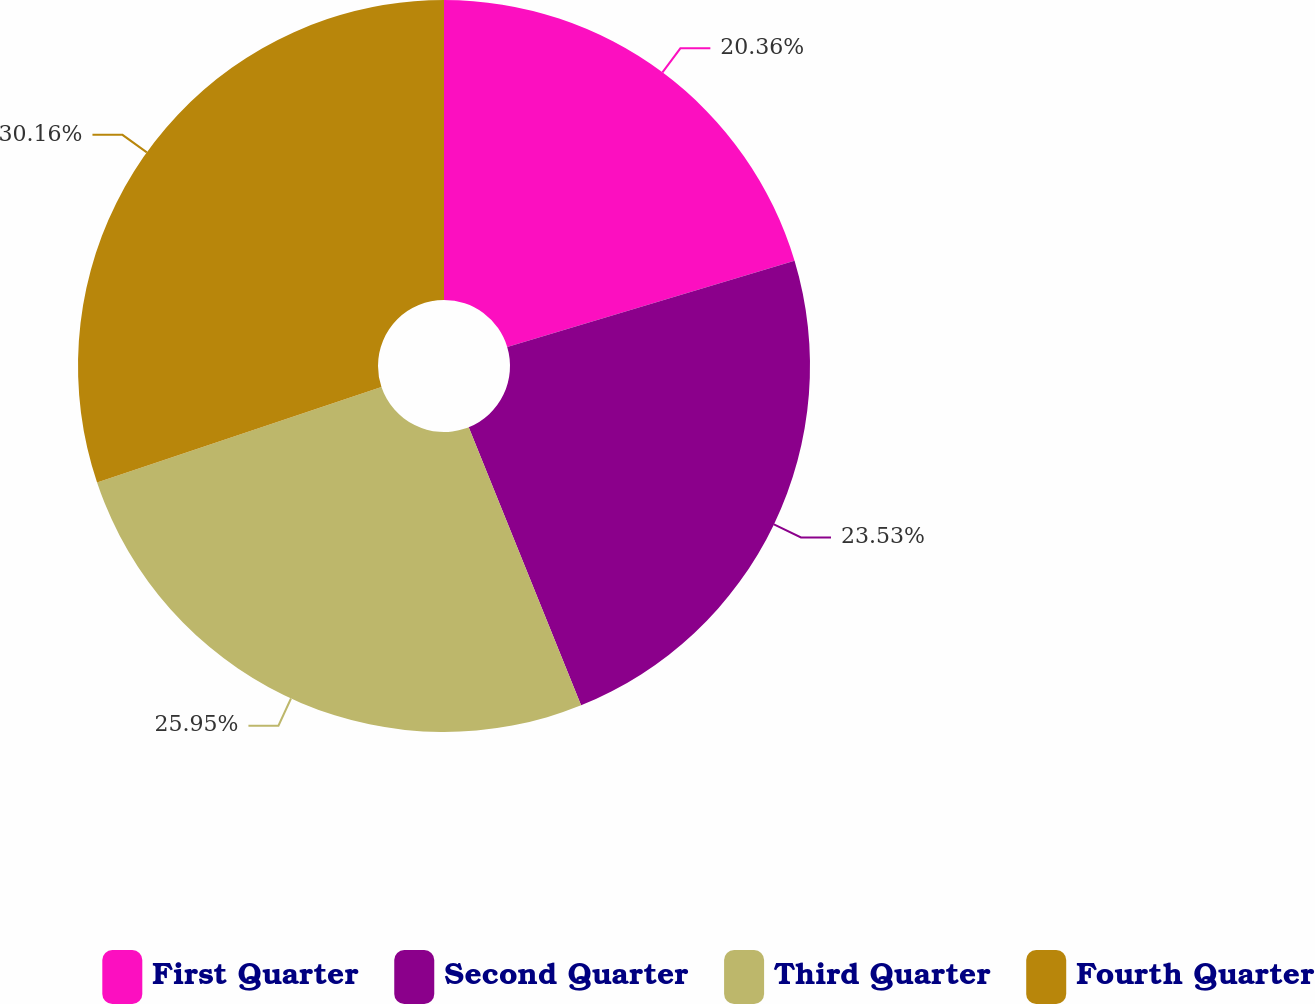Convert chart to OTSL. <chart><loc_0><loc_0><loc_500><loc_500><pie_chart><fcel>First Quarter<fcel>Second Quarter<fcel>Third Quarter<fcel>Fourth Quarter<nl><fcel>20.36%<fcel>23.53%<fcel>25.95%<fcel>30.16%<nl></chart> 